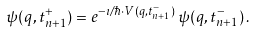Convert formula to latex. <formula><loc_0><loc_0><loc_500><loc_500>\psi ( q , t _ { n + 1 } ^ { + } ) = e ^ { - \imath / \hbar { \cdot } V ( q , t _ { n + 1 } ^ { - } ) } \, \psi ( q , t _ { n + 1 } ^ { - } ) \, .</formula> 